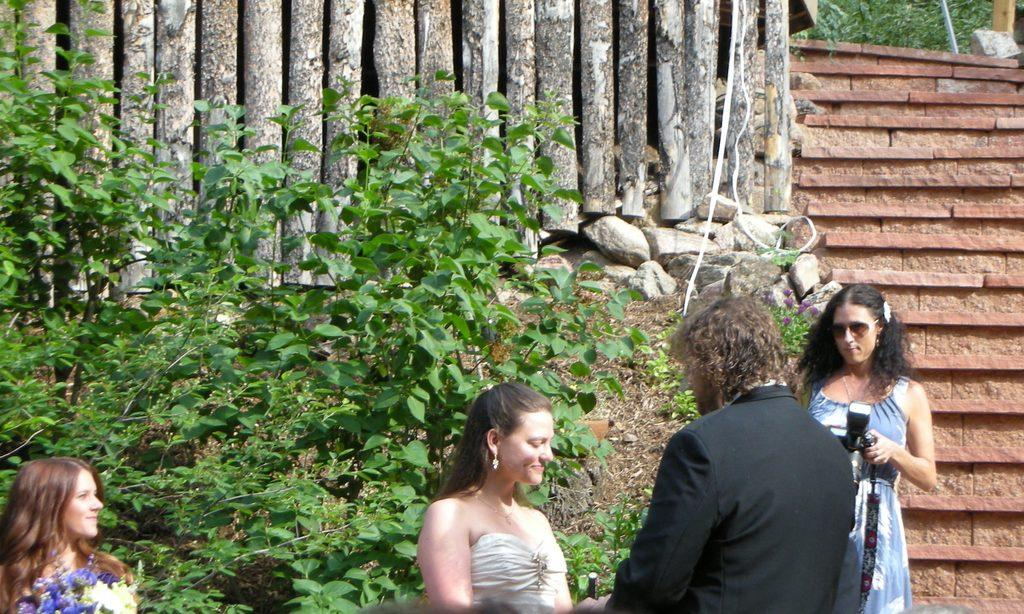How many individuals are present in the image? There are four people standing in the image. What can be seen in the background of the image? There is a tree in the image. How many balls are visible in the image? There are no balls present in the image. 